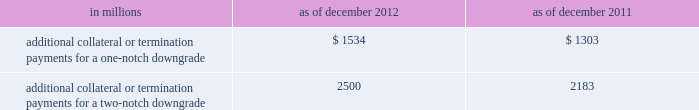Management 2019s discussion and analysis we believe our credit ratings are primarily based on the credit rating agencies 2019 assessment of : 2030 our liquidity , market , credit and operational risk management practices ; 2030 the level and variability of our earnings ; 2030 our capital base ; 2030 our franchise , reputation and management ; 2030 our corporate governance ; and 2030 the external operating environment , including the assumed level of government support .
Certain of the firm 2019s derivatives have been transacted under bilateral agreements with counterparties who may require us to post collateral or terminate the transactions based on changes in our credit ratings .
We assess the impact of these bilateral agreements by determining the collateral or termination payments that would occur assuming a downgrade by all rating agencies .
A downgrade by any one rating agency , depending on the agency 2019s relative ratings of the firm at the time of the downgrade , may have an impact which is comparable to the impact of a downgrade by all rating agencies .
We allocate a portion of our gce to ensure we would be able to make the additional collateral or termination payments that may be required in the event of a two-notch reduction in our long-term credit ratings , as well as collateral that has not been called by counterparties , but is available to them .
The table below presents the additional collateral or termination payments that could have been called at the reporting date by counterparties in the event of a one-notch and two-notch downgrade in our credit ratings. .
In millions 2012 2011 additional collateral or termination payments for a one-notch downgrade $ 1534 $ 1303 additional collateral or termination payments for a two-notch downgrade 2500 2183 cash flows as a global financial institution , our cash flows are complex and bear little relation to our net earnings and net assets .
Consequently , we believe that traditional cash flow analysis is less meaningful in evaluating our liquidity position than the excess liquidity and asset-liability management policies described above .
Cash flow analysis may , however , be helpful in highlighting certain macro trends and strategic initiatives in our businesses .
Year ended december 2012 .
Our cash and cash equivalents increased by $ 16.66 billion to $ 72.67 billion at the end of 2012 .
We generated $ 9.14 billion in net cash from operating and investing activities .
We generated $ 7.52 billion in net cash from financing activities from an increase in bank deposits , partially offset by net repayments of unsecured and secured long-term borrowings .
Year ended december 2011 .
Our cash and cash equivalents increased by $ 16.22 billion to $ 56.01 billion at the end of 2011 .
We generated $ 23.13 billion in net cash from operating and investing activities .
We used net cash of $ 6.91 billion for financing activities , primarily for repurchases of our series g preferred stock and common stock , partially offset by an increase in bank deposits .
Year ended december 2010 .
Our cash and cash equivalents increased by $ 1.50 billion to $ 39.79 billion at the end of 2010 .
We generated $ 7.84 billion in net cash from financing activities primarily from net proceeds from issuances of short-term secured financings .
We used net cash of $ 6.34 billion for operating and investing activities , primarily to fund an increase in securities purchased under agreements to resell and an increase in cash and securities segregated for regulatory and other purposes , partially offset by cash generated from a decrease in securities borrowed .
Goldman sachs 2012 annual report 87 .
What were cash and cash equivalents in billions at the end of 2011? 
Computations: (72.67 - 16.66)
Answer: 56.01. 